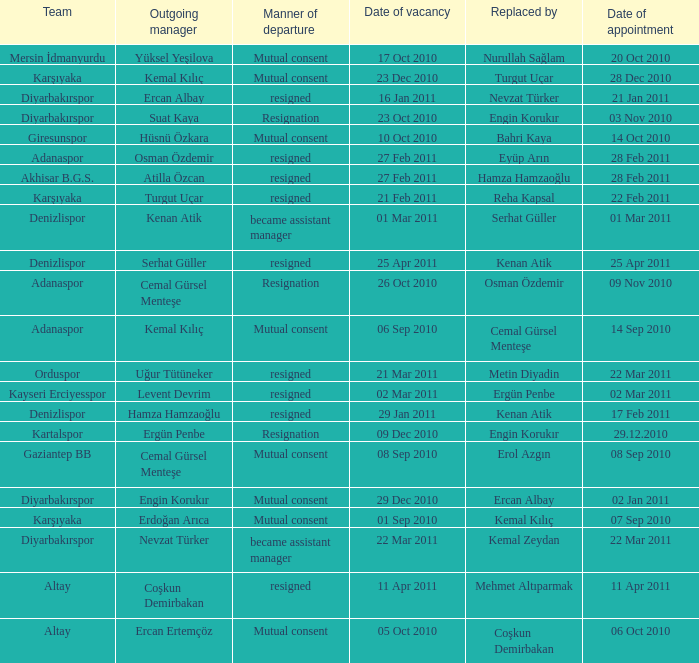Who replaced the outgoing manager Hüsnü Özkara?  Bahri Kaya. 